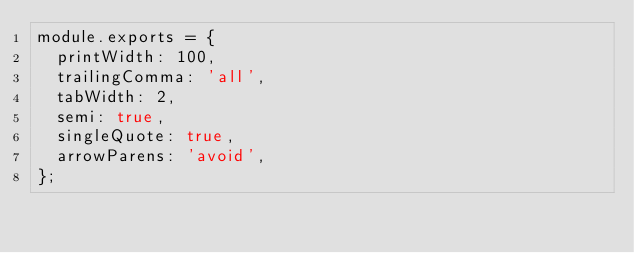Convert code to text. <code><loc_0><loc_0><loc_500><loc_500><_JavaScript_>module.exports = {
  printWidth: 100,
  trailingComma: 'all',
  tabWidth: 2,
  semi: true,
  singleQuote: true,
  arrowParens: 'avoid',
};
</code> 